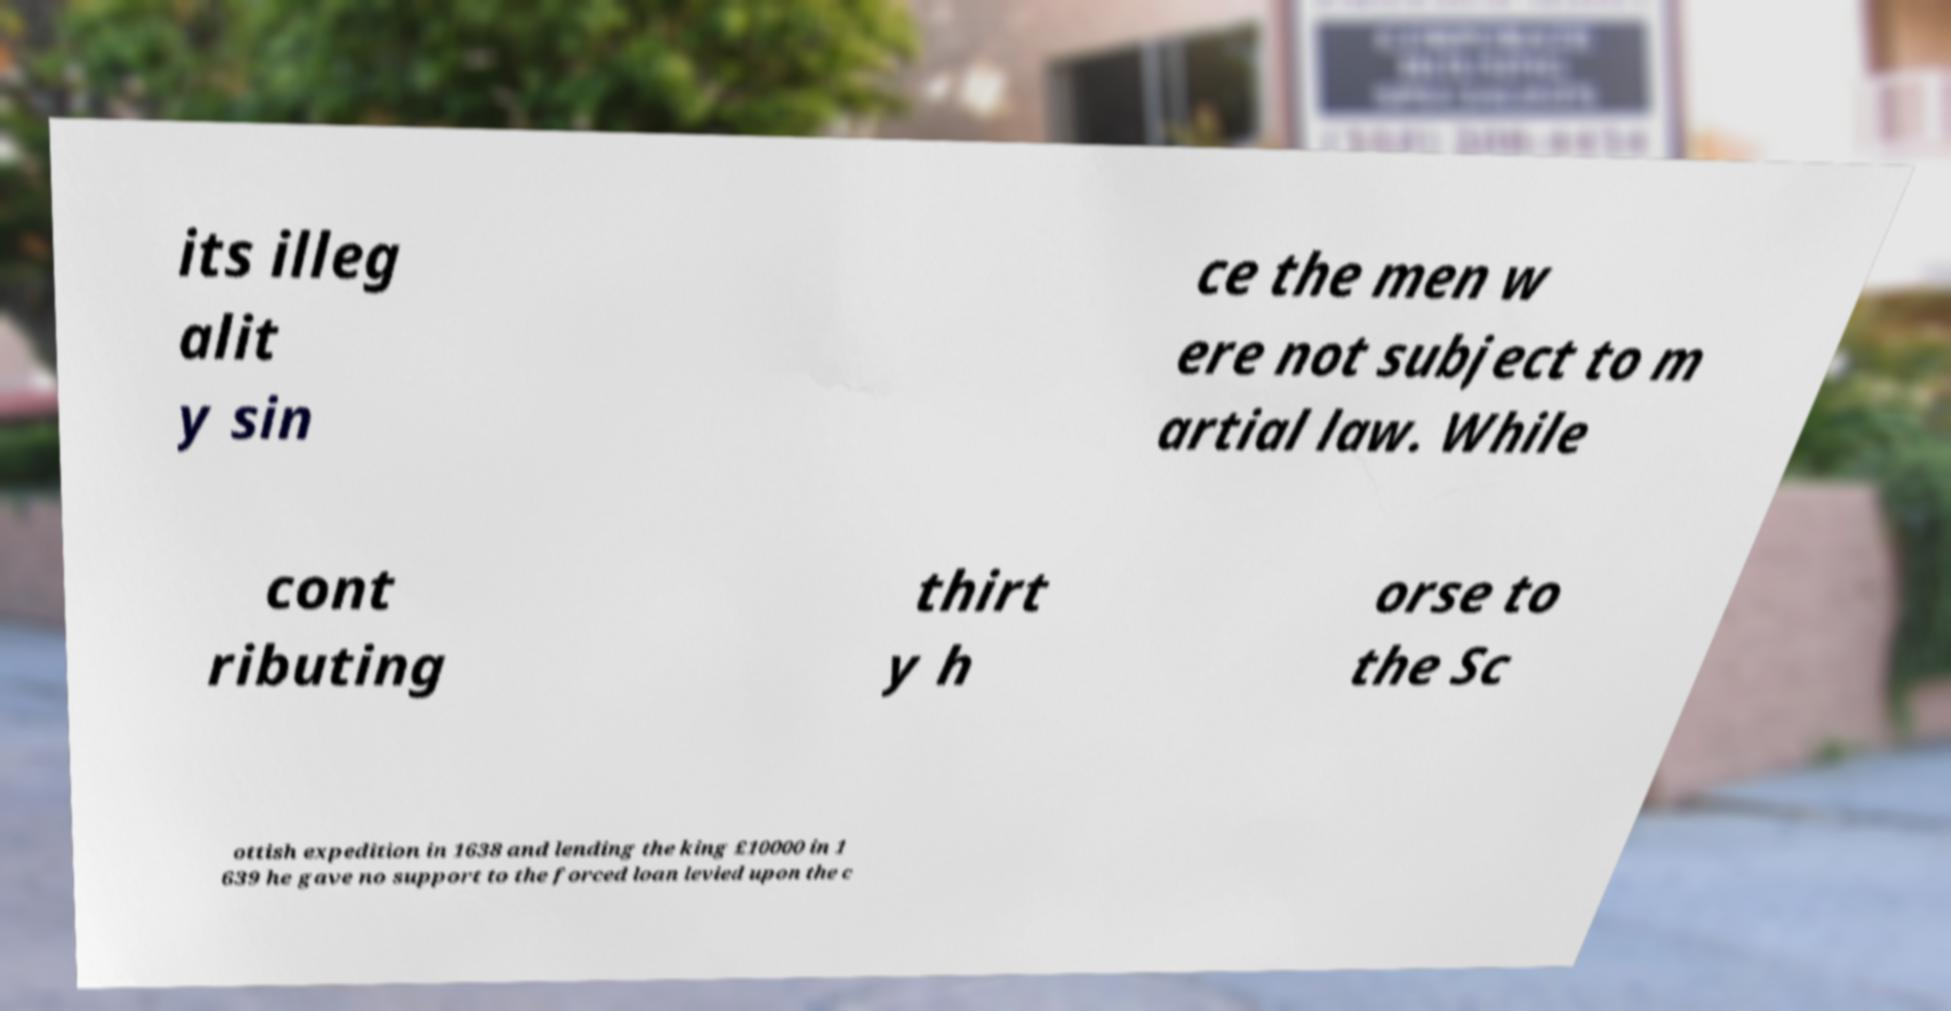Can you read and provide the text displayed in the image?This photo seems to have some interesting text. Can you extract and type it out for me? its illeg alit y sin ce the men w ere not subject to m artial law. While cont ributing thirt y h orse to the Sc ottish expedition in 1638 and lending the king £10000 in 1 639 he gave no support to the forced loan levied upon the c 